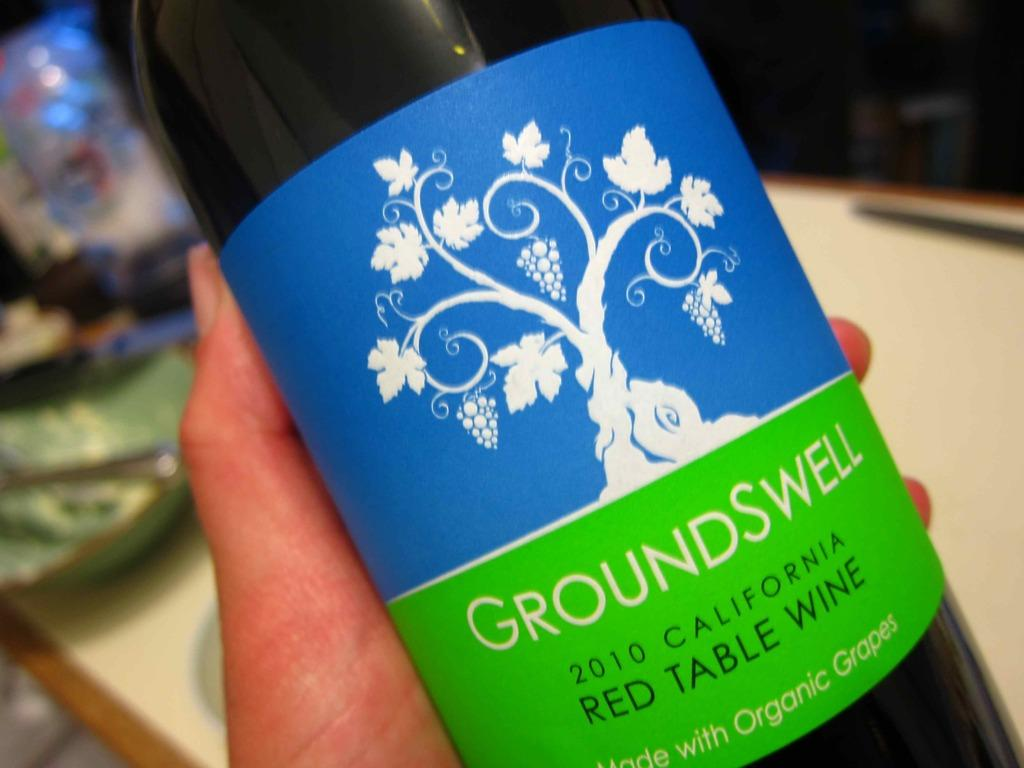What object is present in the image with writing on it? There is a bottle in the image with "GroundSwell" written on it. Can you describe the bottle in more detail? The bottle has "GroundSwell" written on it. What else can be seen in the image? A person's hand is visible in the image. What type of instrument is the person playing in the image? There is no instrument present in the image; only a bottle with "GroundSwell" written on it and a person's hand are visible. 